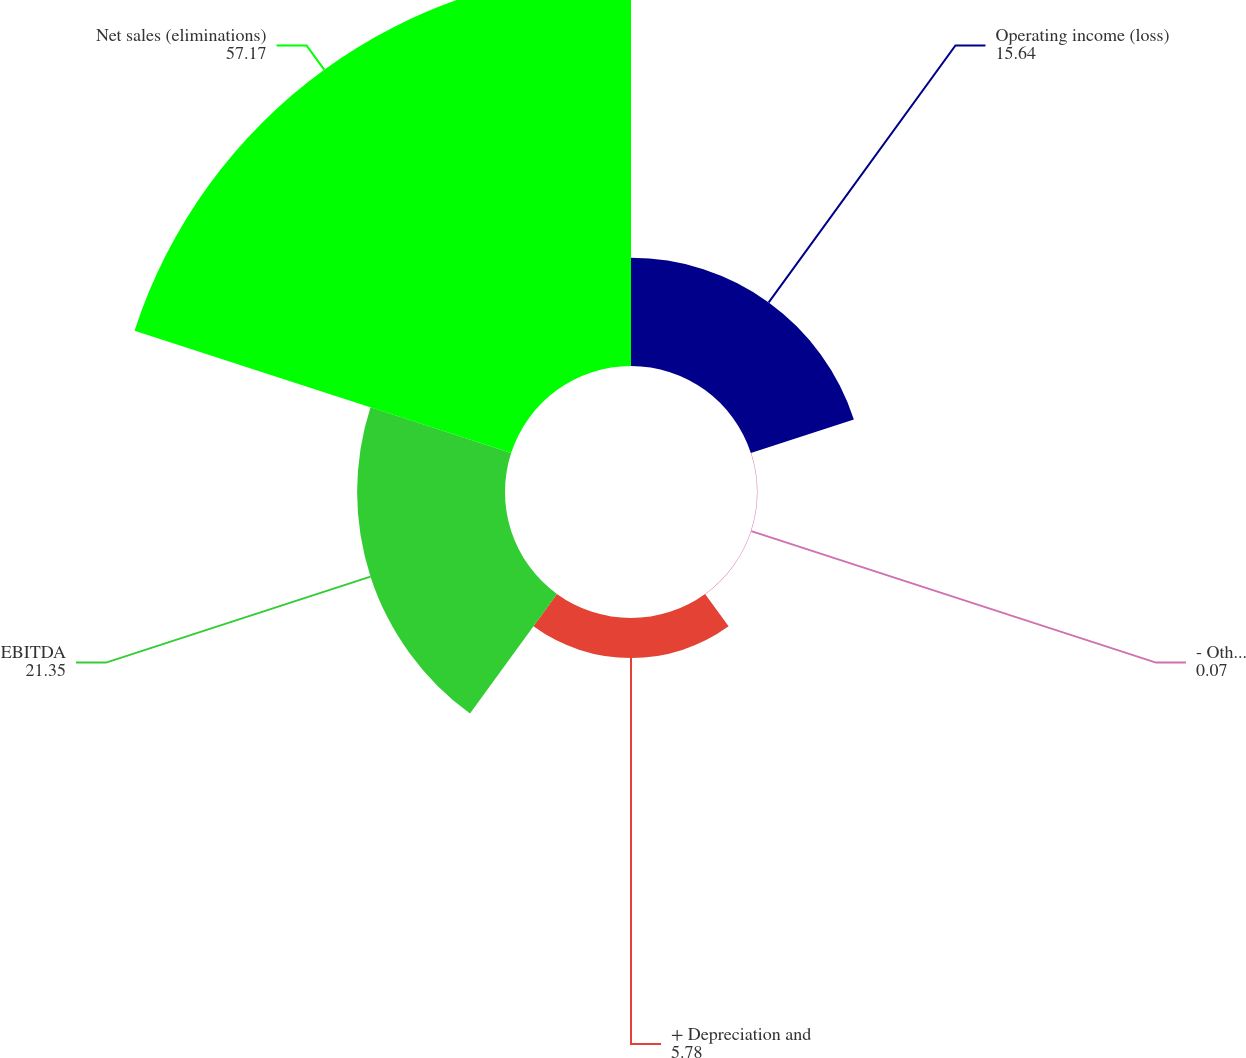<chart> <loc_0><loc_0><loc_500><loc_500><pie_chart><fcel>Operating income (loss)<fcel>- Other (income) expense - net<fcel>+ Depreciation and<fcel>EBITDA<fcel>Net sales (eliminations)<nl><fcel>15.64%<fcel>0.07%<fcel>5.78%<fcel>21.35%<fcel>57.17%<nl></chart> 